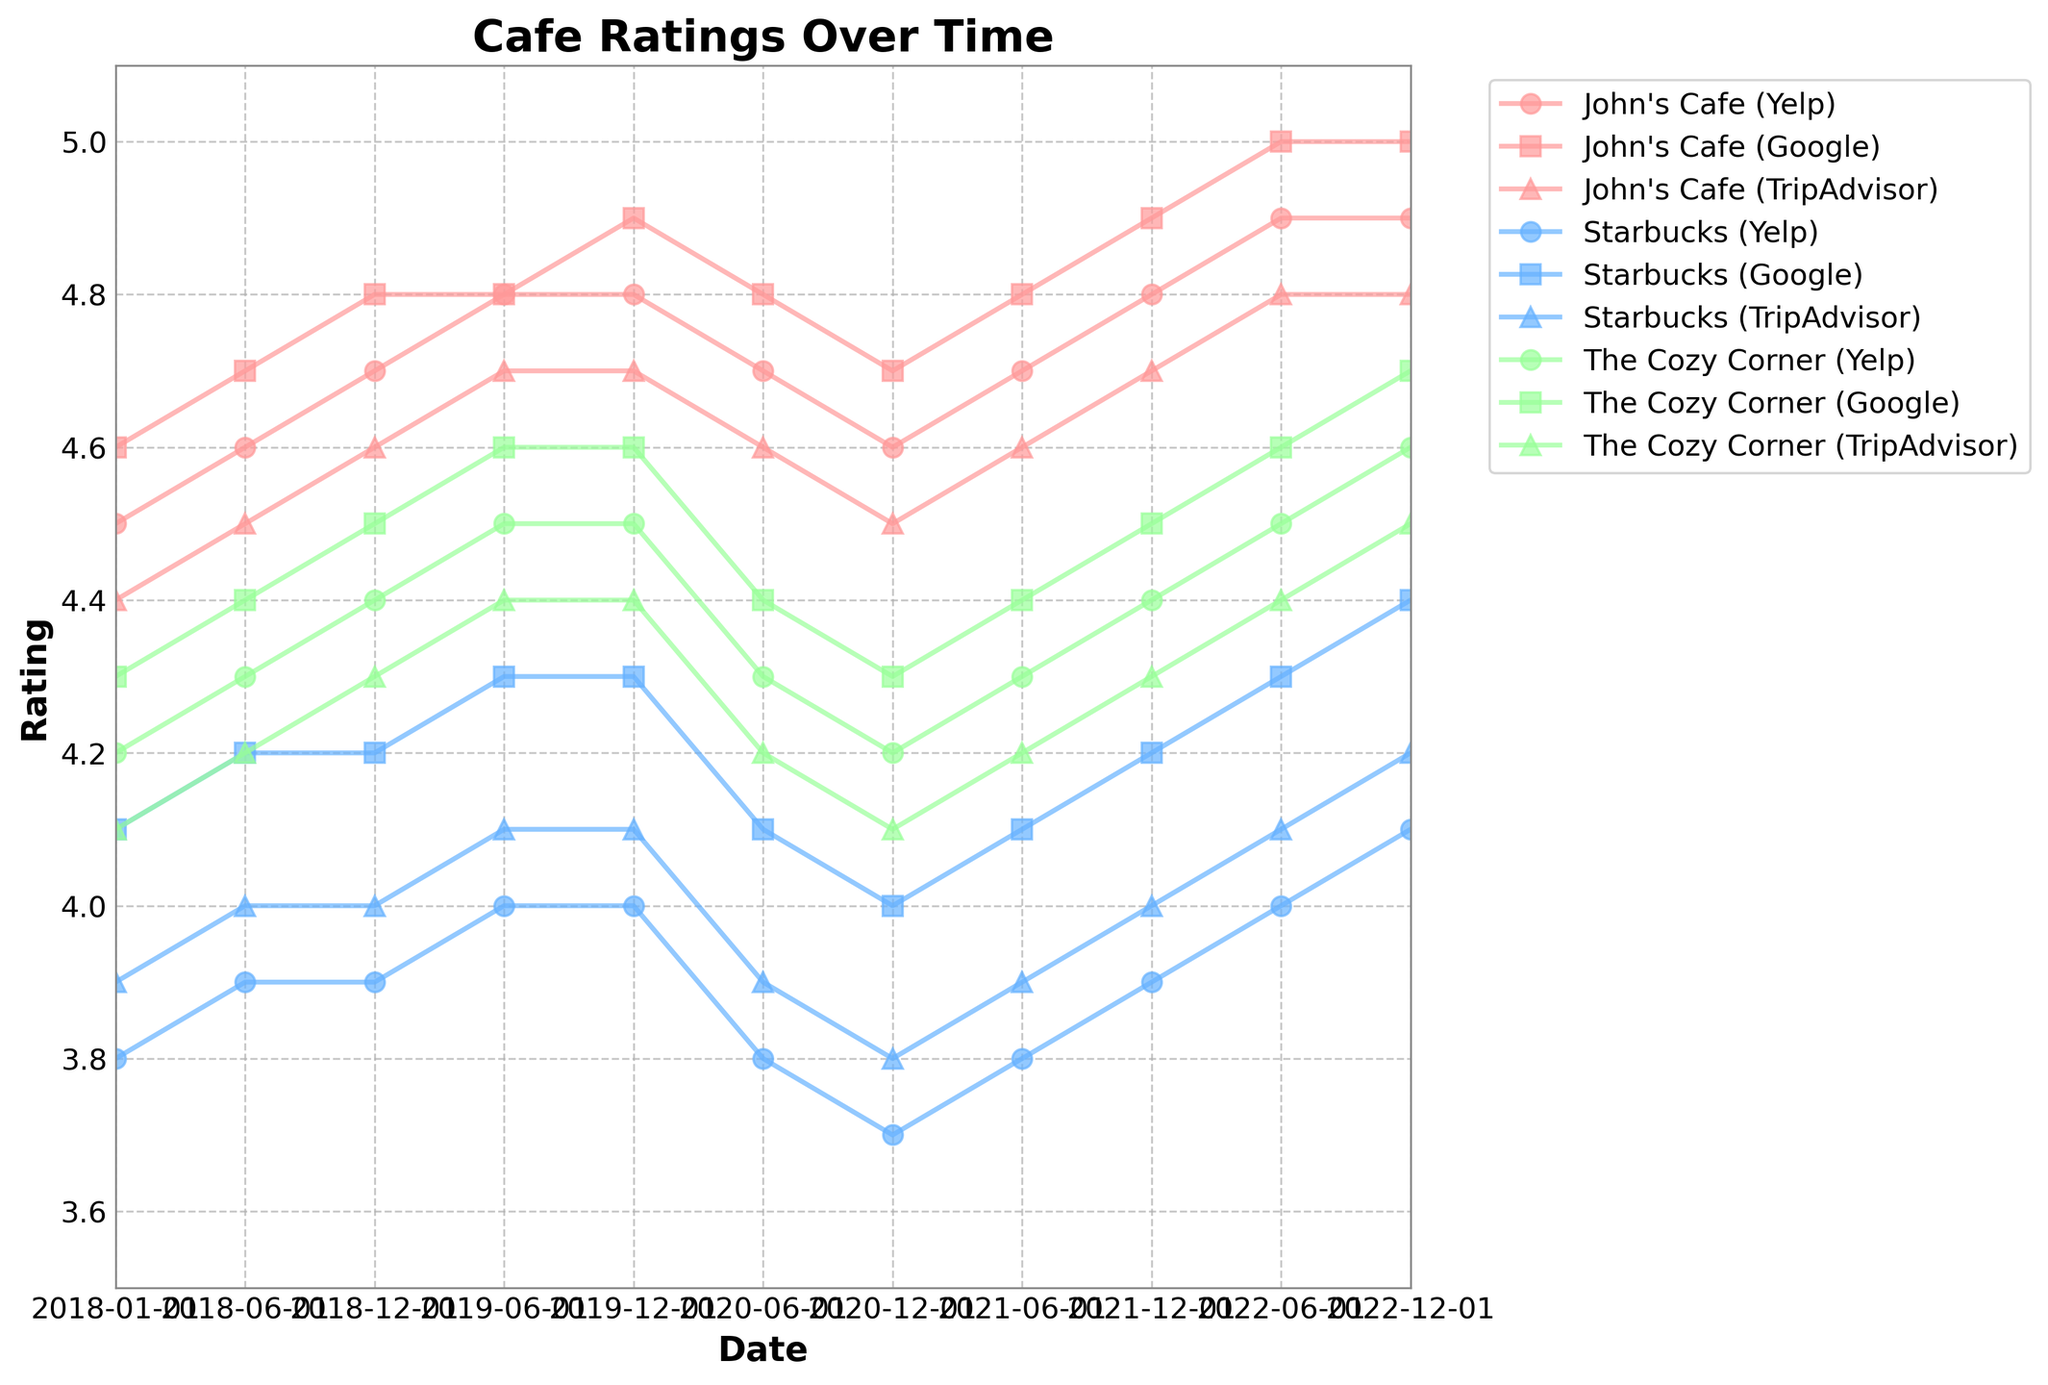Which platform shows the highest rating for John's Cafe in 2022? Looking at the points for 2022 in the line chart for John's Cafe, the highest points on the vertical scale corresponds to 5.0 on Google.
Answer: Google Between June 2020 and December 2020, did the ratings for John's Cafe on Yelp increase, decrease, or stay the same? Check the line representing John's Cafe on Yelp between those two dates in the figure. The rating decreases from 4.7 to 4.6.
Answer: Decrease On which date did The Cozy Corner first achieve a higher rating on Yelp than Starbucks on Google's platform? Looking at the trends in the line chart, The Cozy Corner first surpasses Starbucks on Google in June 2020, which is 4.3 compared to 4.1.
Answer: June 2020 Which cafe had the most improvement on Yelp from the beginning of 2018 to the end of 2022? By examining the distance between the initial and final points on the Yelp lines for each cafe, John's Cafe shows the largest increase (from 4.5 to 4.9).
Answer: John's Cafe What is the average rating of John's Cafe across all platforms in June 2022? Average the ratings of John's Cafe across Yelp, Google, and TripAdvisor in June 2022. (4.9 + 5.0 + 4.8) / 3 = 4.9.
Answer: 4.9 In December 2020, which cafe had the lowest rating on TripAdvisor and what was it? Observing the downward trends, Starbucks had the lowest rating on TripAdvisor with a 3.8 rating.
Answer: Starbucks, 3.8 Was there any point where Starbucks had a higher rating than The Cozy Corner on Yelp? By investigating the lines for Starbucks and The Cozy Corner on Yelp, Starbucks never surpassed The Cozy Corner at any shown date.
Answer: No Calculate the median Yelp rating for John's Cafe from 2018 to 2022. Arrange the Yelp ratings for John's Cafe in ascending order (4.5, 4.6, 4.6, 4.7, 4.7, 4.7, 4.8, 4.8, 4.8, 4.9, 4.9). The middle value is 4.7, which is the median.
Answer: 4.7 Between which two dates did John's Cafe on Google have the least change in rating? The change between dates is smallest where the line is most horizontal. From Dec 2018 to June 2019, the rating remains at 4.8.
Answer: Dec 2018 and June 2019 What is the trend for The Cozy Corner's ratings on TripAdvisor over time? By following the line for The Cozy Corner on TripAdvisor, the ratings show a steady increase from 4.1 in 2018 to 4.5 in 2022.
Answer: Increasing 